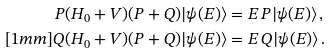<formula> <loc_0><loc_0><loc_500><loc_500>P ( H _ { 0 } + V ) ( P + Q ) | \psi ( E ) \rangle & = E \, P | \psi ( E ) \rangle \, , \\ [ 1 m m ] Q ( H _ { 0 } + V ) ( P + Q ) | \psi ( E ) \rangle & = E \, Q | \psi ( E ) \rangle \, .</formula> 